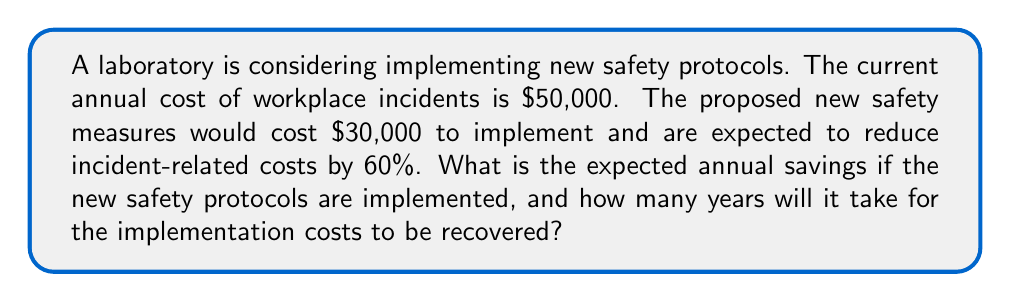Teach me how to tackle this problem. Let's break this problem down step-by-step:

1. Calculate the reduced incident cost after implementing new safety measures:
   Current annual incident cost: $50,000
   Reduction in incidents: 60% = 0.60
   
   New annual incident cost = $50,000 * (1 - 0.60) = $50,000 * 0.40 = $20,000

2. Calculate the annual savings:
   Annual savings = Current incident cost - New incident cost
   $$ \text{Annual savings} = $50,000 - $20,000 = $30,000 $$

3. Calculate the net annual savings after accounting for implementation costs:
   Implementation cost: $30,000
   
   Net annual savings = Annual savings - Implementation cost
   $$ \text{Net annual savings} = $30,000 - $30,000 = $0 $$

4. Calculate the payback period (time to recover implementation costs):
   Payback period = Implementation cost ÷ Annual savings
   $$ \text{Payback period} = \frac{$30,000}{$30,000} = 1 \text{ year} $$

The laboratory will break even after the first year, and then save $30,000 annually in subsequent years.
Answer: The expected annual savings are $30,000, and it will take 1 year for the implementation costs to be recovered. 